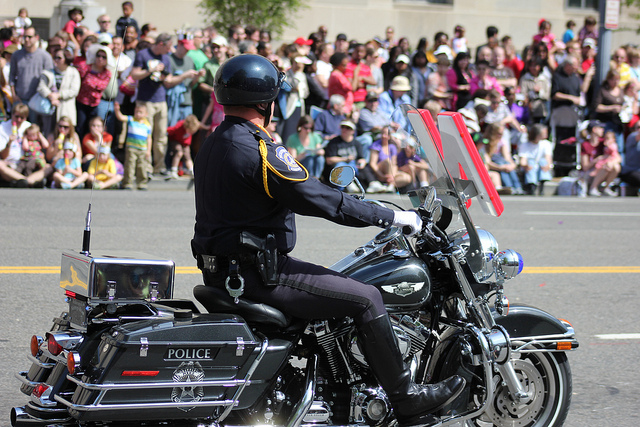Extract all visible text content from this image. POLICE 